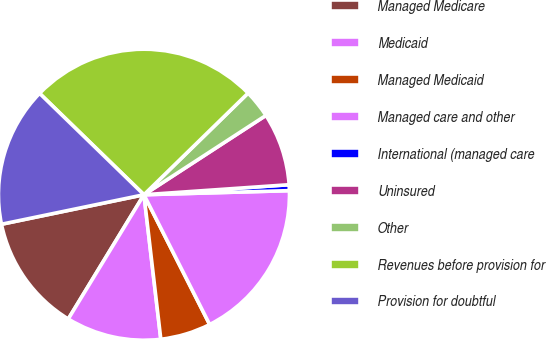<chart> <loc_0><loc_0><loc_500><loc_500><pie_chart><fcel>Managed Medicare<fcel>Medicaid<fcel>Managed Medicaid<fcel>Managed care and other<fcel>International (managed care<fcel>Uninsured<fcel>Other<fcel>Revenues before provision for<fcel>Provision for doubtful<nl><fcel>13.04%<fcel>10.56%<fcel>5.61%<fcel>17.99%<fcel>0.65%<fcel>8.08%<fcel>3.13%<fcel>25.43%<fcel>15.52%<nl></chart> 